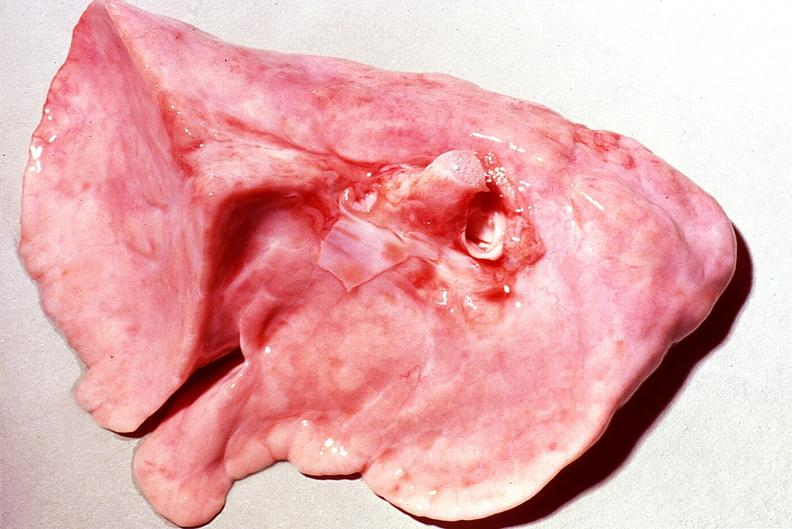s respiratory present?
Answer the question using a single word or phrase. Yes 